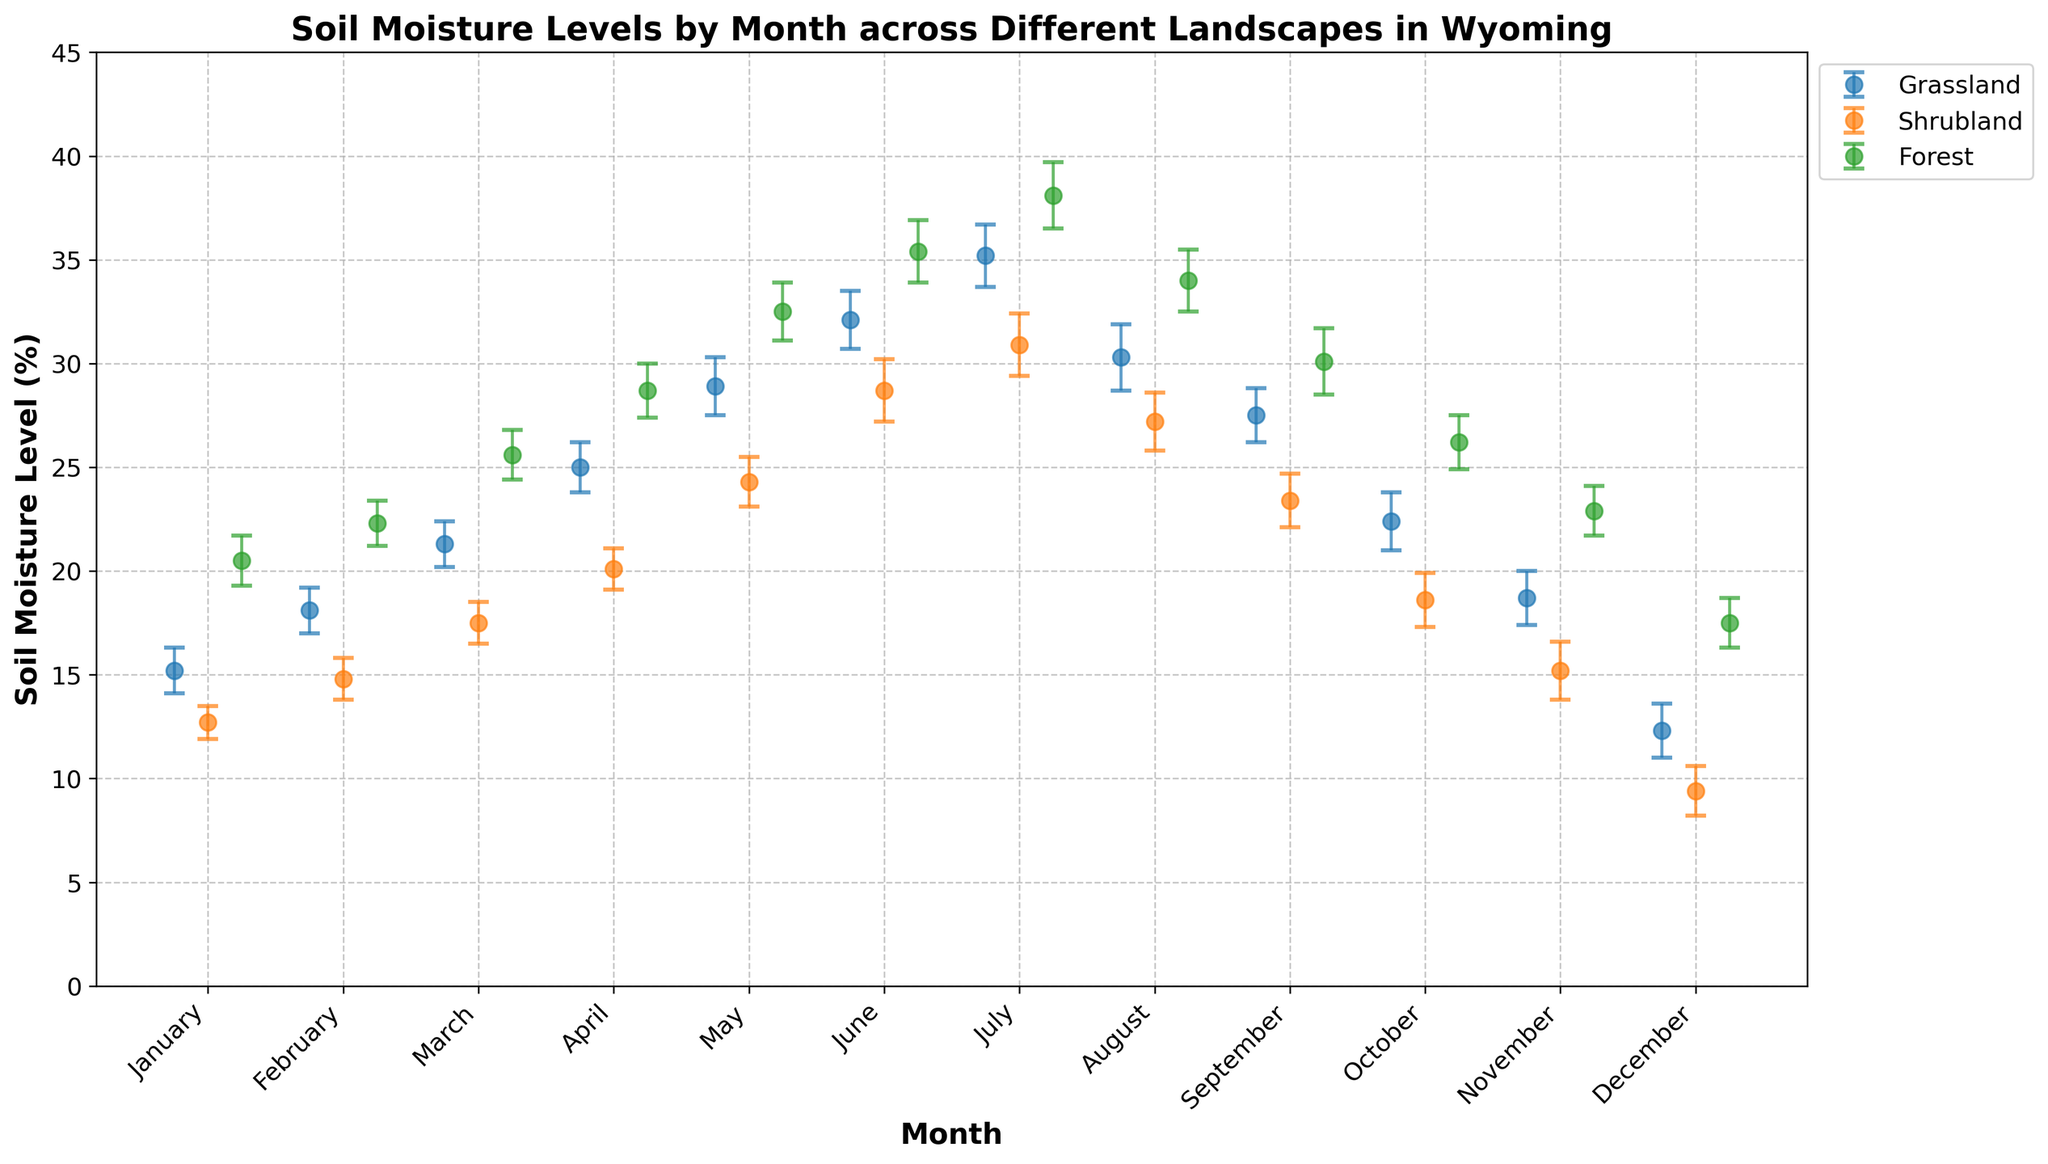What's the title of the figure? The title of the figure is usually located at the top of the plot. In this case, it reads "Soil Moisture Levels by Month across Different Landscapes in Wyoming".
Answer: Soil Moisture Levels by Month across Different Landscapes in Wyoming What is the highest mean soil moisture level recorded in any month and landscape? By observing the error bars and dots, the highest mean soil moisture level recorded is in July for the Forest landscape, at 38.1%.
Answer: 38.1% In which month is the soil moisture level the lowest in Shrubland? By checking the dots that represent Shrubland in each month, the lowest soil moisture level for Shrubland is in December, at 9.4%.
Answer: December How do the error bars for Forest and Grassland in May compare? In May, the Forest landscape error bars stretch from approximately 31.1% to 33.9%, while Grassland error bars go from approximately 27.5% to 30.3%. Hence, Forest error bars are generally higher than those for Grassland.
Answer: Forest error bars are higher Which landscape shows the greatest variability in soil moisture levels throughout the year? To find the greatest variability, observe the range of soil moisture levels through the months. Forest shows the greatest range, from a low of 17.5% in December to a high of 38.1% in July.
Answer: Forest Are the soil moisture levels in Grassland higher in May or September? By how much? In May, the mean soil moisture level for Grassland is 28.9%, while in September, it is 27.5%. To find the difference, subtract 27.5 from 28.9, which equals 1.4%.
Answer: May by 1.4% Which month has the smallest confidence intervals for Shrubland? The confidence interval is smallest when the error bars are shortest. For Shrubland, the smallest CI is in January, with levels ranging approximately from 11.9% to 13.5%.
Answer: January Compare the mean soil moisture levels in October for all landscapes. Which one has the highest level? In October, the mean soil moisture levels are 22.4% for Grassland, 18.6% for Shrubland, and 26.2% for Forest. Therefore, Forest has the highest level.
Answer: Forest How many months do Forest landscapes have a mean soil moisture level higher than 30%? By examining the Forest data points, the mean soil moisture level exceeded 30% in five months: April, May, June, July, and August.
Answer: 5 